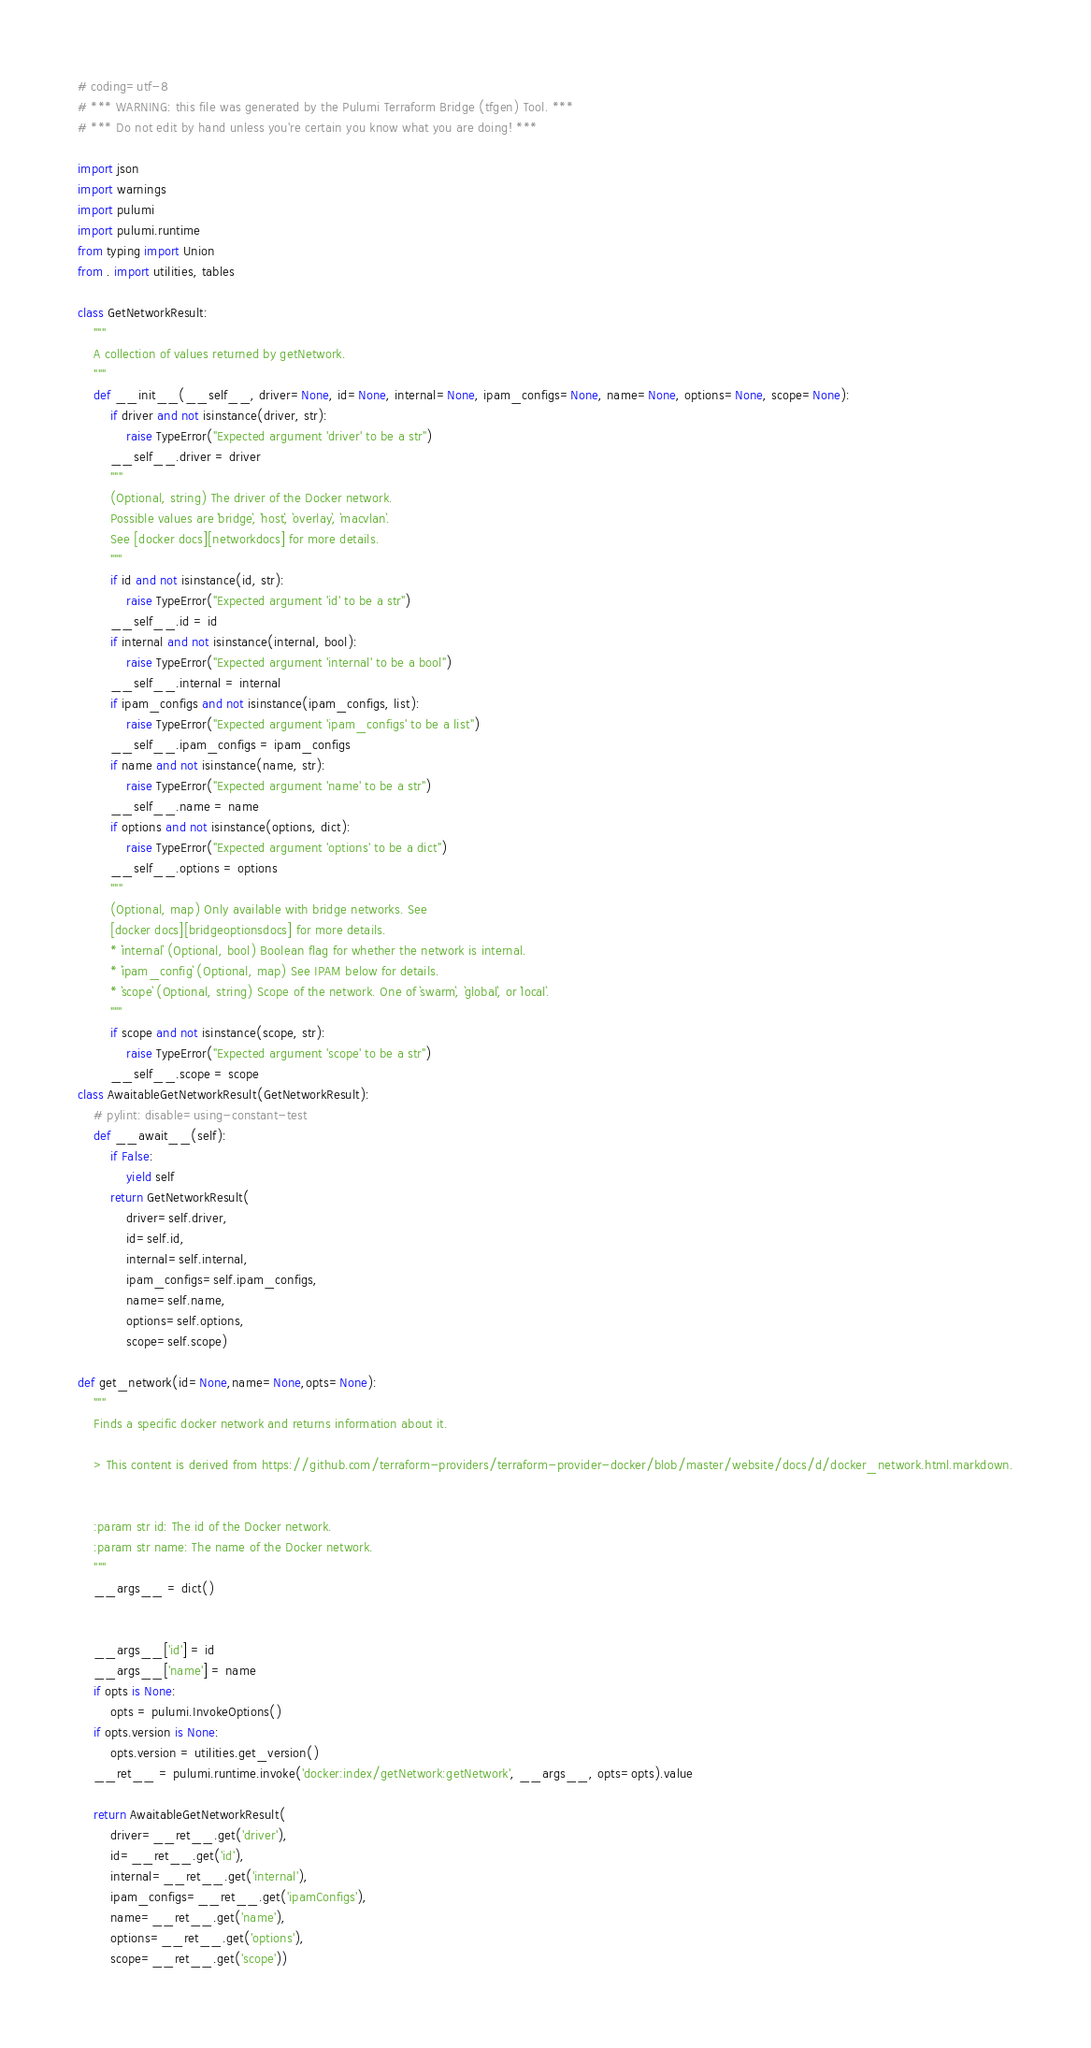Convert code to text. <code><loc_0><loc_0><loc_500><loc_500><_Python_># coding=utf-8
# *** WARNING: this file was generated by the Pulumi Terraform Bridge (tfgen) Tool. ***
# *** Do not edit by hand unless you're certain you know what you are doing! ***

import json
import warnings
import pulumi
import pulumi.runtime
from typing import Union
from . import utilities, tables

class GetNetworkResult:
    """
    A collection of values returned by getNetwork.
    """
    def __init__(__self__, driver=None, id=None, internal=None, ipam_configs=None, name=None, options=None, scope=None):
        if driver and not isinstance(driver, str):
            raise TypeError("Expected argument 'driver' to be a str")
        __self__.driver = driver
        """
        (Optional, string) The driver of the Docker network. 
        Possible values are `bridge`, `host`, `overlay`, `macvlan`.
        See [docker docs][networkdocs] for more details.
        """
        if id and not isinstance(id, str):
            raise TypeError("Expected argument 'id' to be a str")
        __self__.id = id
        if internal and not isinstance(internal, bool):
            raise TypeError("Expected argument 'internal' to be a bool")
        __self__.internal = internal
        if ipam_configs and not isinstance(ipam_configs, list):
            raise TypeError("Expected argument 'ipam_configs' to be a list")
        __self__.ipam_configs = ipam_configs
        if name and not isinstance(name, str):
            raise TypeError("Expected argument 'name' to be a str")
        __self__.name = name
        if options and not isinstance(options, dict):
            raise TypeError("Expected argument 'options' to be a dict")
        __self__.options = options
        """
        (Optional, map) Only available with bridge networks. See
        [docker docs][bridgeoptionsdocs] for more details.
        * `internal` (Optional, bool) Boolean flag for whether the network is internal.
        * `ipam_config` (Optional, map) See IPAM below for details.
        * `scope` (Optional, string) Scope of the network. One of `swarm`, `global`, or `local`.
        """
        if scope and not isinstance(scope, str):
            raise TypeError("Expected argument 'scope' to be a str")
        __self__.scope = scope
class AwaitableGetNetworkResult(GetNetworkResult):
    # pylint: disable=using-constant-test
    def __await__(self):
        if False:
            yield self
        return GetNetworkResult(
            driver=self.driver,
            id=self.id,
            internal=self.internal,
            ipam_configs=self.ipam_configs,
            name=self.name,
            options=self.options,
            scope=self.scope)

def get_network(id=None,name=None,opts=None):
    """
    Finds a specific docker network and returns information about it.

    > This content is derived from https://github.com/terraform-providers/terraform-provider-docker/blob/master/website/docs/d/docker_network.html.markdown.


    :param str id: The id of the Docker network.
    :param str name: The name of the Docker network.
    """
    __args__ = dict()


    __args__['id'] = id
    __args__['name'] = name
    if opts is None:
        opts = pulumi.InvokeOptions()
    if opts.version is None:
        opts.version = utilities.get_version()
    __ret__ = pulumi.runtime.invoke('docker:index/getNetwork:getNetwork', __args__, opts=opts).value

    return AwaitableGetNetworkResult(
        driver=__ret__.get('driver'),
        id=__ret__.get('id'),
        internal=__ret__.get('internal'),
        ipam_configs=__ret__.get('ipamConfigs'),
        name=__ret__.get('name'),
        options=__ret__.get('options'),
        scope=__ret__.get('scope'))
</code> 